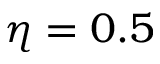Convert formula to latex. <formula><loc_0><loc_0><loc_500><loc_500>\eta = 0 . 5</formula> 